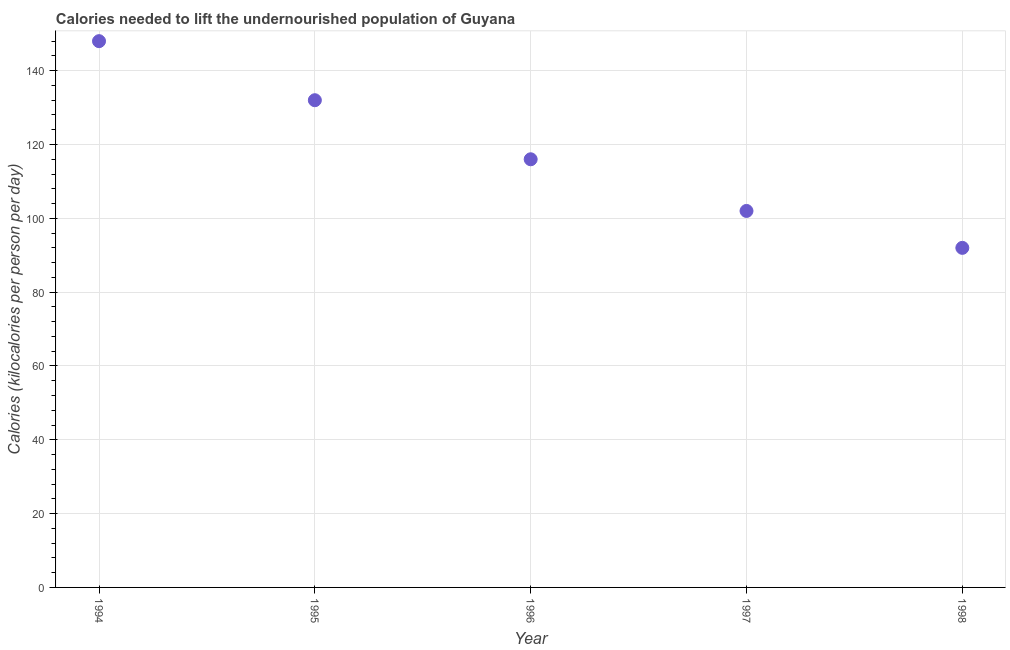What is the depth of food deficit in 1997?
Offer a terse response. 102. Across all years, what is the maximum depth of food deficit?
Provide a short and direct response. 148. Across all years, what is the minimum depth of food deficit?
Ensure brevity in your answer.  92. What is the sum of the depth of food deficit?
Your answer should be very brief. 590. What is the difference between the depth of food deficit in 1995 and 1997?
Ensure brevity in your answer.  30. What is the average depth of food deficit per year?
Your answer should be compact. 118. What is the median depth of food deficit?
Keep it short and to the point. 116. Do a majority of the years between 1998 and 1997 (inclusive) have depth of food deficit greater than 8 kilocalories?
Offer a terse response. No. What is the ratio of the depth of food deficit in 1994 to that in 1998?
Your response must be concise. 1.61. Is the depth of food deficit in 1995 less than that in 1996?
Provide a short and direct response. No. Is the difference between the depth of food deficit in 1994 and 1995 greater than the difference between any two years?
Ensure brevity in your answer.  No. What is the difference between the highest and the second highest depth of food deficit?
Ensure brevity in your answer.  16. Is the sum of the depth of food deficit in 1996 and 1997 greater than the maximum depth of food deficit across all years?
Your answer should be compact. Yes. What is the difference between the highest and the lowest depth of food deficit?
Make the answer very short. 56. Does the depth of food deficit monotonically increase over the years?
Provide a short and direct response. No. How many years are there in the graph?
Offer a terse response. 5. Does the graph contain any zero values?
Give a very brief answer. No. What is the title of the graph?
Your answer should be very brief. Calories needed to lift the undernourished population of Guyana. What is the label or title of the Y-axis?
Your answer should be compact. Calories (kilocalories per person per day). What is the Calories (kilocalories per person per day) in 1994?
Give a very brief answer. 148. What is the Calories (kilocalories per person per day) in 1995?
Your answer should be very brief. 132. What is the Calories (kilocalories per person per day) in 1996?
Give a very brief answer. 116. What is the Calories (kilocalories per person per day) in 1997?
Your answer should be compact. 102. What is the Calories (kilocalories per person per day) in 1998?
Your answer should be very brief. 92. What is the difference between the Calories (kilocalories per person per day) in 1994 and 1996?
Provide a succinct answer. 32. What is the difference between the Calories (kilocalories per person per day) in 1994 and 1997?
Give a very brief answer. 46. What is the difference between the Calories (kilocalories per person per day) in 1995 and 1996?
Your answer should be compact. 16. What is the difference between the Calories (kilocalories per person per day) in 1995 and 1997?
Make the answer very short. 30. What is the difference between the Calories (kilocalories per person per day) in 1995 and 1998?
Make the answer very short. 40. What is the difference between the Calories (kilocalories per person per day) in 1996 and 1997?
Your answer should be very brief. 14. What is the difference between the Calories (kilocalories per person per day) in 1996 and 1998?
Your answer should be very brief. 24. What is the ratio of the Calories (kilocalories per person per day) in 1994 to that in 1995?
Your response must be concise. 1.12. What is the ratio of the Calories (kilocalories per person per day) in 1994 to that in 1996?
Keep it short and to the point. 1.28. What is the ratio of the Calories (kilocalories per person per day) in 1994 to that in 1997?
Provide a short and direct response. 1.45. What is the ratio of the Calories (kilocalories per person per day) in 1994 to that in 1998?
Make the answer very short. 1.61. What is the ratio of the Calories (kilocalories per person per day) in 1995 to that in 1996?
Offer a very short reply. 1.14. What is the ratio of the Calories (kilocalories per person per day) in 1995 to that in 1997?
Ensure brevity in your answer.  1.29. What is the ratio of the Calories (kilocalories per person per day) in 1995 to that in 1998?
Offer a terse response. 1.44. What is the ratio of the Calories (kilocalories per person per day) in 1996 to that in 1997?
Give a very brief answer. 1.14. What is the ratio of the Calories (kilocalories per person per day) in 1996 to that in 1998?
Keep it short and to the point. 1.26. What is the ratio of the Calories (kilocalories per person per day) in 1997 to that in 1998?
Keep it short and to the point. 1.11. 